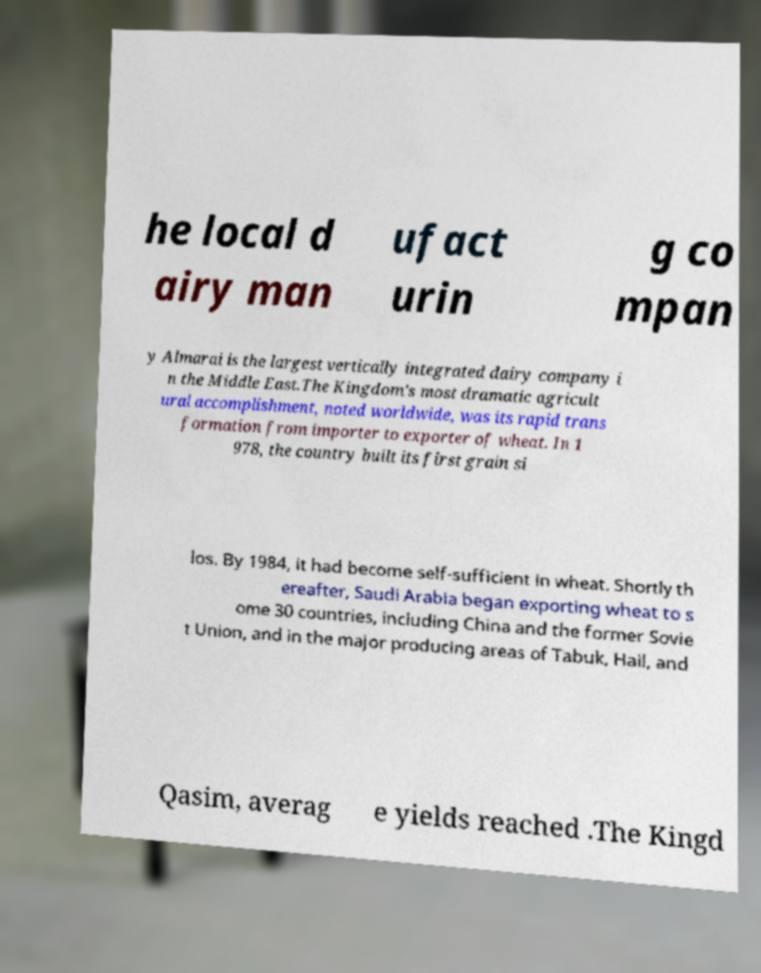For documentation purposes, I need the text within this image transcribed. Could you provide that? he local d airy man ufact urin g co mpan y Almarai is the largest vertically integrated dairy company i n the Middle East.The Kingdom's most dramatic agricult ural accomplishment, noted worldwide, was its rapid trans formation from importer to exporter of wheat. In 1 978, the country built its first grain si los. By 1984, it had become self-sufficient in wheat. Shortly th ereafter, Saudi Arabia began exporting wheat to s ome 30 countries, including China and the former Sovie t Union, and in the major producing areas of Tabuk, Hail, and Qasim, averag e yields reached .The Kingd 